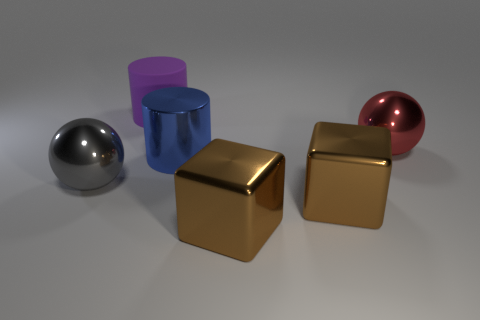Add 2 big green cubes. How many objects exist? 8 Subtract all cylinders. How many objects are left? 4 Subtract all large blue shiny objects. Subtract all brown blocks. How many objects are left? 3 Add 2 red metal things. How many red metal things are left? 3 Add 2 large cylinders. How many large cylinders exist? 4 Subtract 1 blue cylinders. How many objects are left? 5 